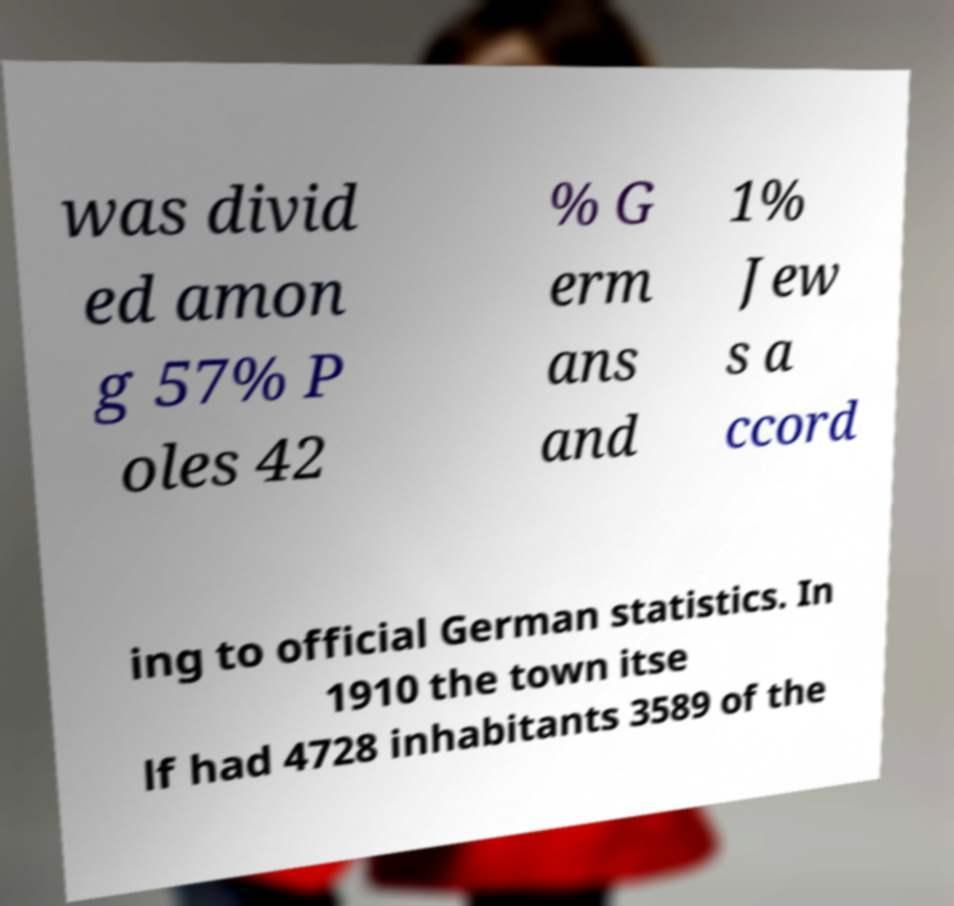Could you extract and type out the text from this image? was divid ed amon g 57% P oles 42 % G erm ans and 1% Jew s a ccord ing to official German statistics. In 1910 the town itse lf had 4728 inhabitants 3589 of the 